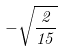<formula> <loc_0><loc_0><loc_500><loc_500>- \sqrt { \frac { 2 } { 1 5 } }</formula> 